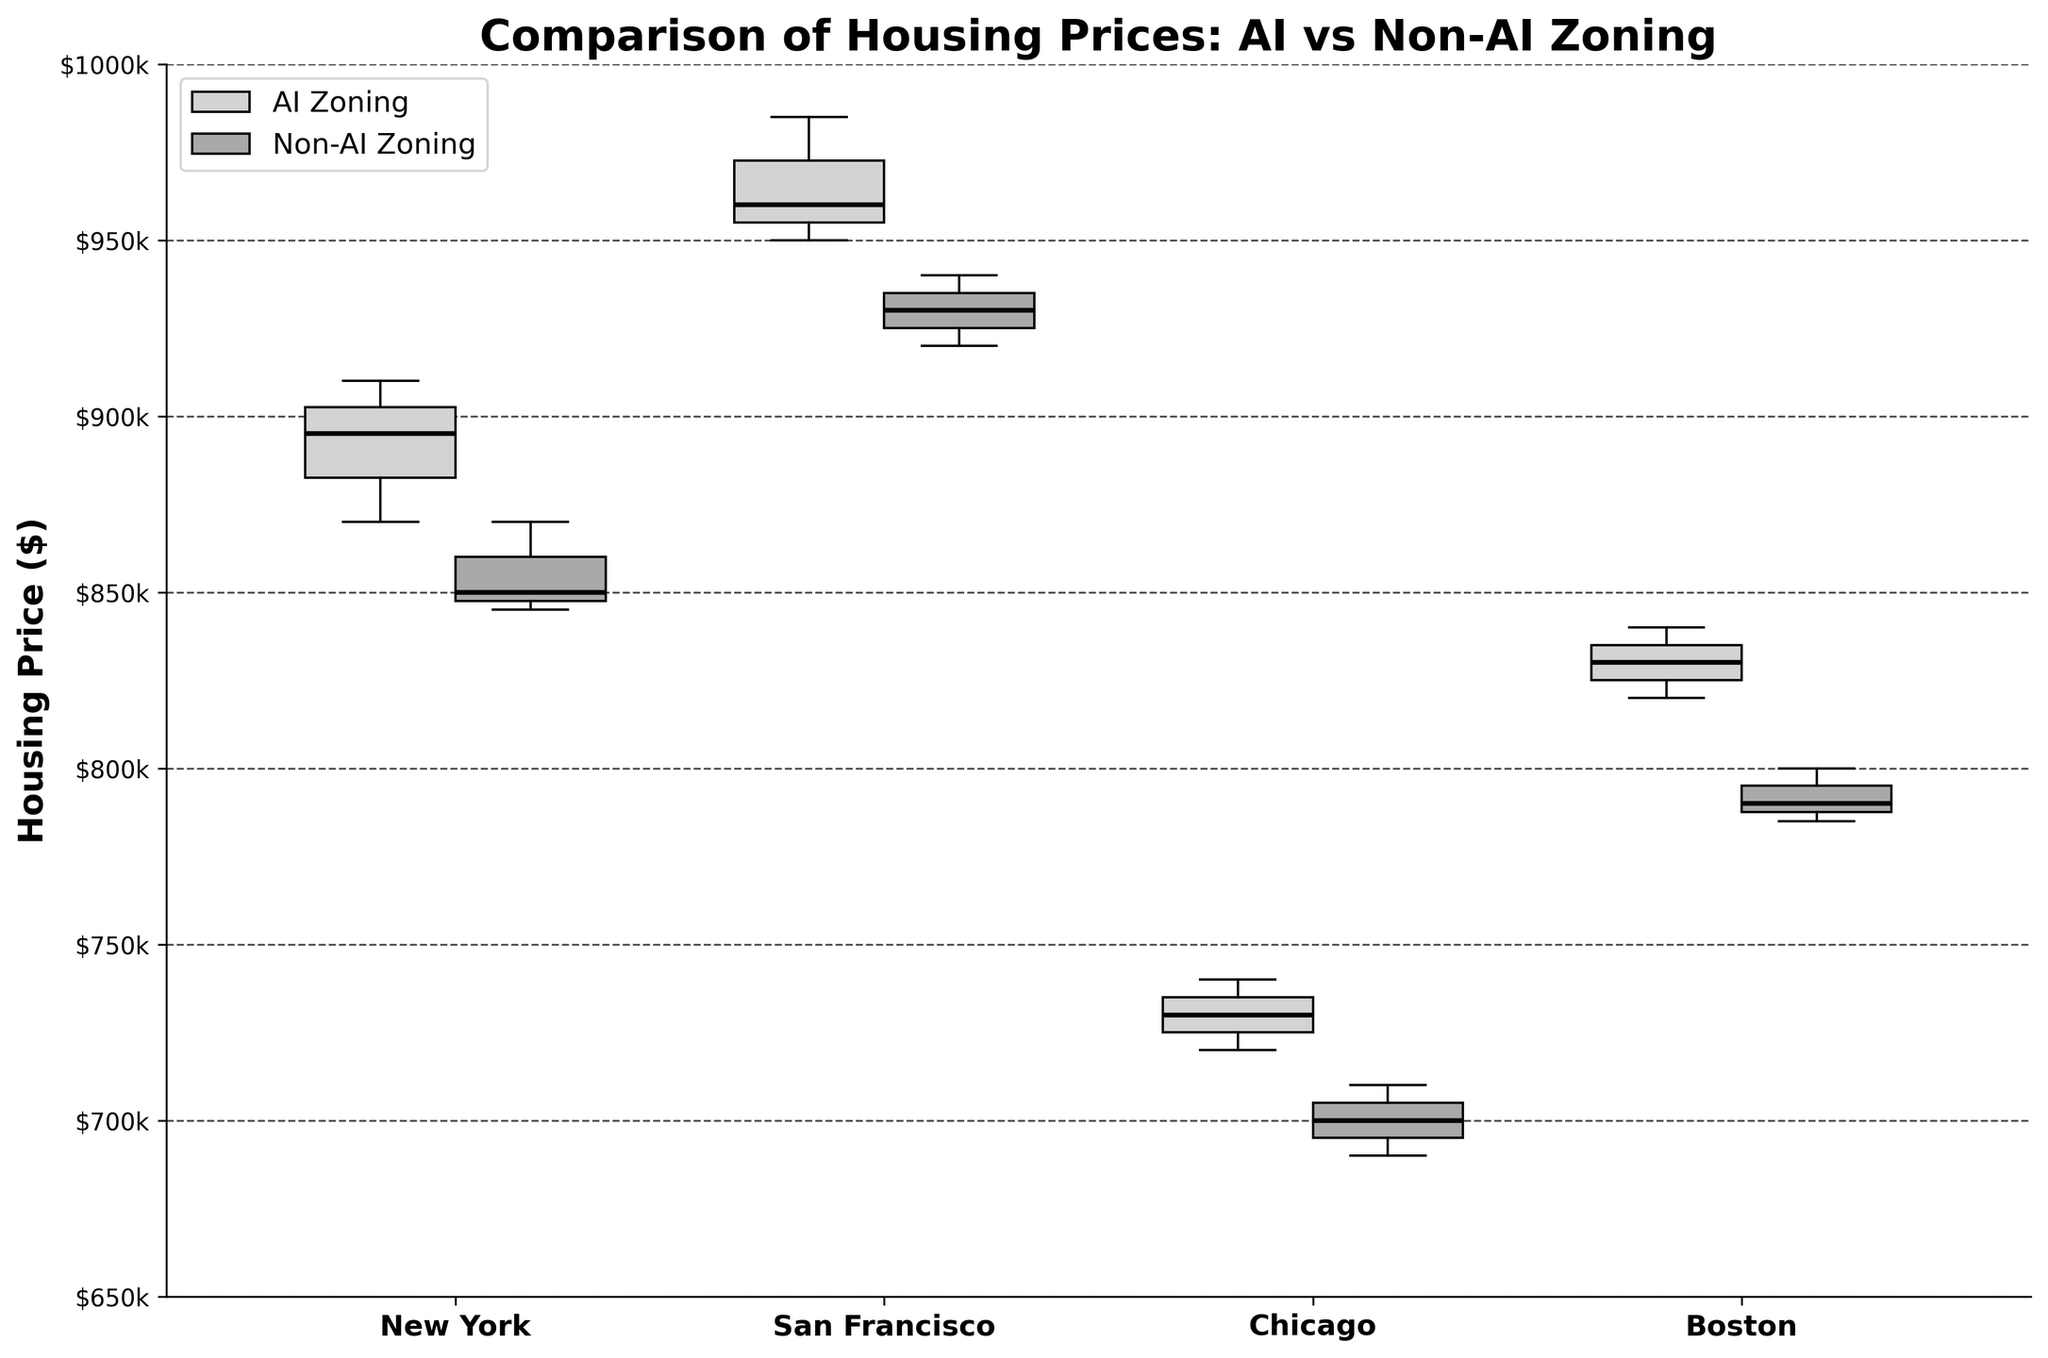What's the title of the plot? The title of the plot is displayed at the top, which describes what the plot is about. By reading the title, we can understand the primary focus of the visualization.
Answer: Comparison of Housing Prices: AI vs Non-AI Zoning What does the y-axis represent? The y-axis label indicates what is being measured on the vertical axis. By reading the label on the y-axis, we can identify that it represents housing prices in dollars.
Answer: Housing Price ($) Which city has the highest median housing price in AI zones? To find the highest median housing price in AI zones, look at the bold horizontal line in the middle of the AI box plots for each city. Compare these medians and identify the highest one.
Answer: San Francisco What is the median housing price in non-AI zones for New York? Locate the box plot representing non-AI housing prices for New York. The median is marked by the bold horizontal line within the box. This gives the value directly.
Answer: $850,000 Is there a city where the median housing prices are higher in non-AI zones compared to AI zones? Compare the medians (bold lines) of the AI and non-AI box plots for each city. Check if the bold line in the non-AI zone box plot is higher than the corresponding AI zone box plot.
Answer: No In which city is the spread (range) of housing prices in the AI zones the largest? The spread of housing prices is identified by the length of the box and the whiskers in each box plot. Compare these lengths for the AI zones across all cities to determine the largest spread.
Answer: New York How does the housing price range in non-AI zones in Boston compare to that in Chicago? For each city's non-AI zone, compare the length of the whiskers and the box to identify the range. Subtract the smallest value from the largest value within the box plot.
Answer: The range in Boston is $15,000, and in Chicago, it is $20,000. Chicago has a larger range Which city shows the smallest difference between median prices of AI and non-AI zones? Calculate the difference between the medians of AI and non-AI zones for each city by subtracting one from the other. The smallest absolute difference identifies the city.
Answer: Chicago How many data points are likely represented in each box plot for San Francisco? Each box plot typically represents several data points. By looking at the discrete points shown as possible outliers, one can estimate the number of points each plot represents. The summary statistics (min, Q1, median, Q3, max) indicate the data points.
Answer: 3 data points in each box plot Which zones (AI or non-AI) generally have higher housing prices in most cities? By reviewing the position of the medians (bold lines) of the box plots for AI and non-AI zones across all cities, we can identify if one consistently has higher values.
Answer: AI zones 